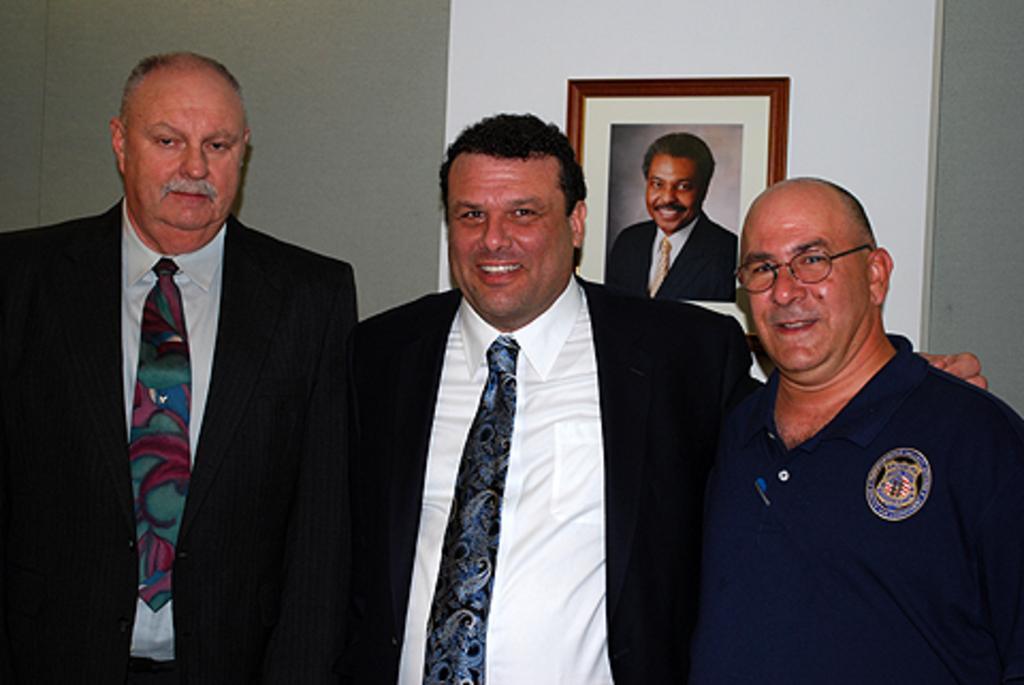In one or two sentences, can you explain what this image depicts? In this image there are three persons standing with a smile on their face, behind them there is a photo frame hanging on the wall. 